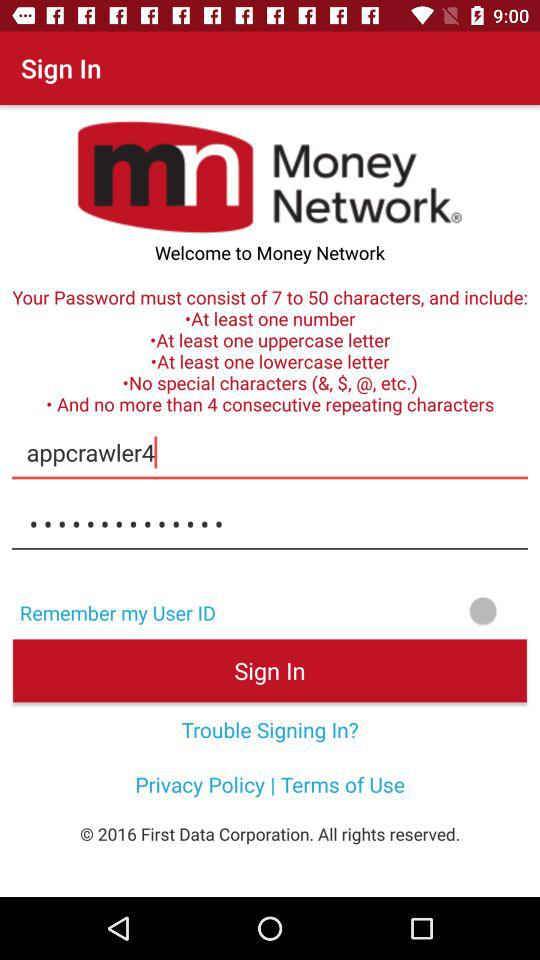What's the status of "Remember my User ID"? The status of "Remember my User ID" is "off". 